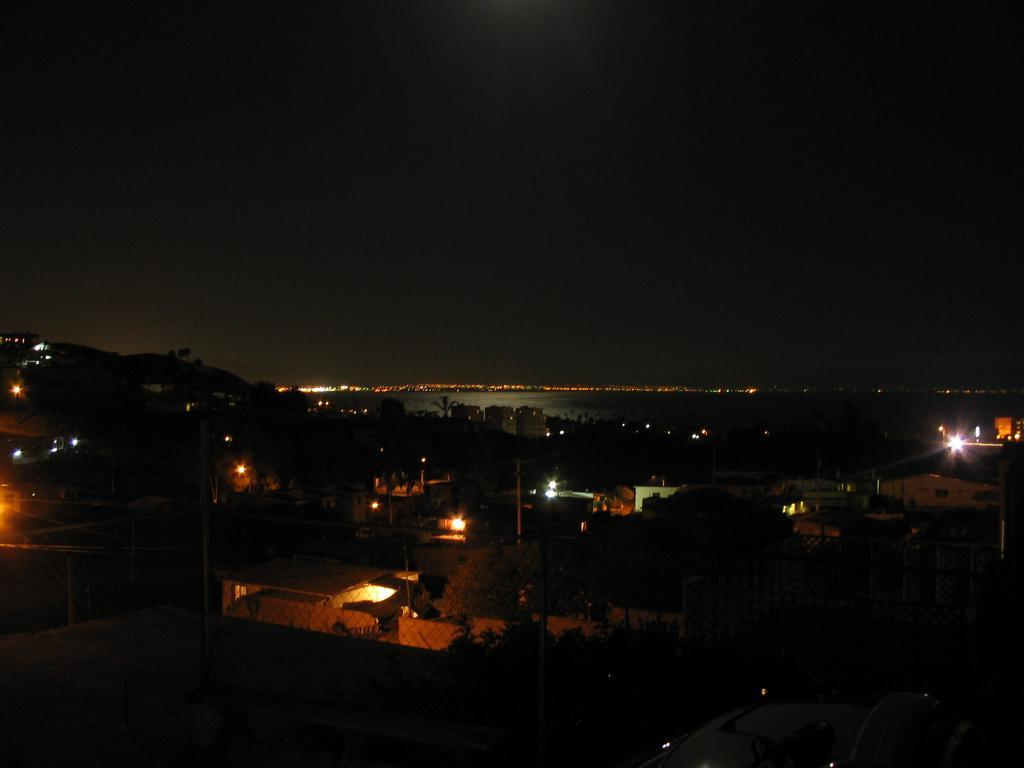What is located at the bottom of the image? There are trees, poles, lights, and buildings at the bottom of the image. What can be found in the middle of the image? There is water in the middle of the image. Can you tell me how many examples of the ocean can be seen in the image? There is no ocean present in the image. What type of lake is visible in the image? There is no lake present in the image. 